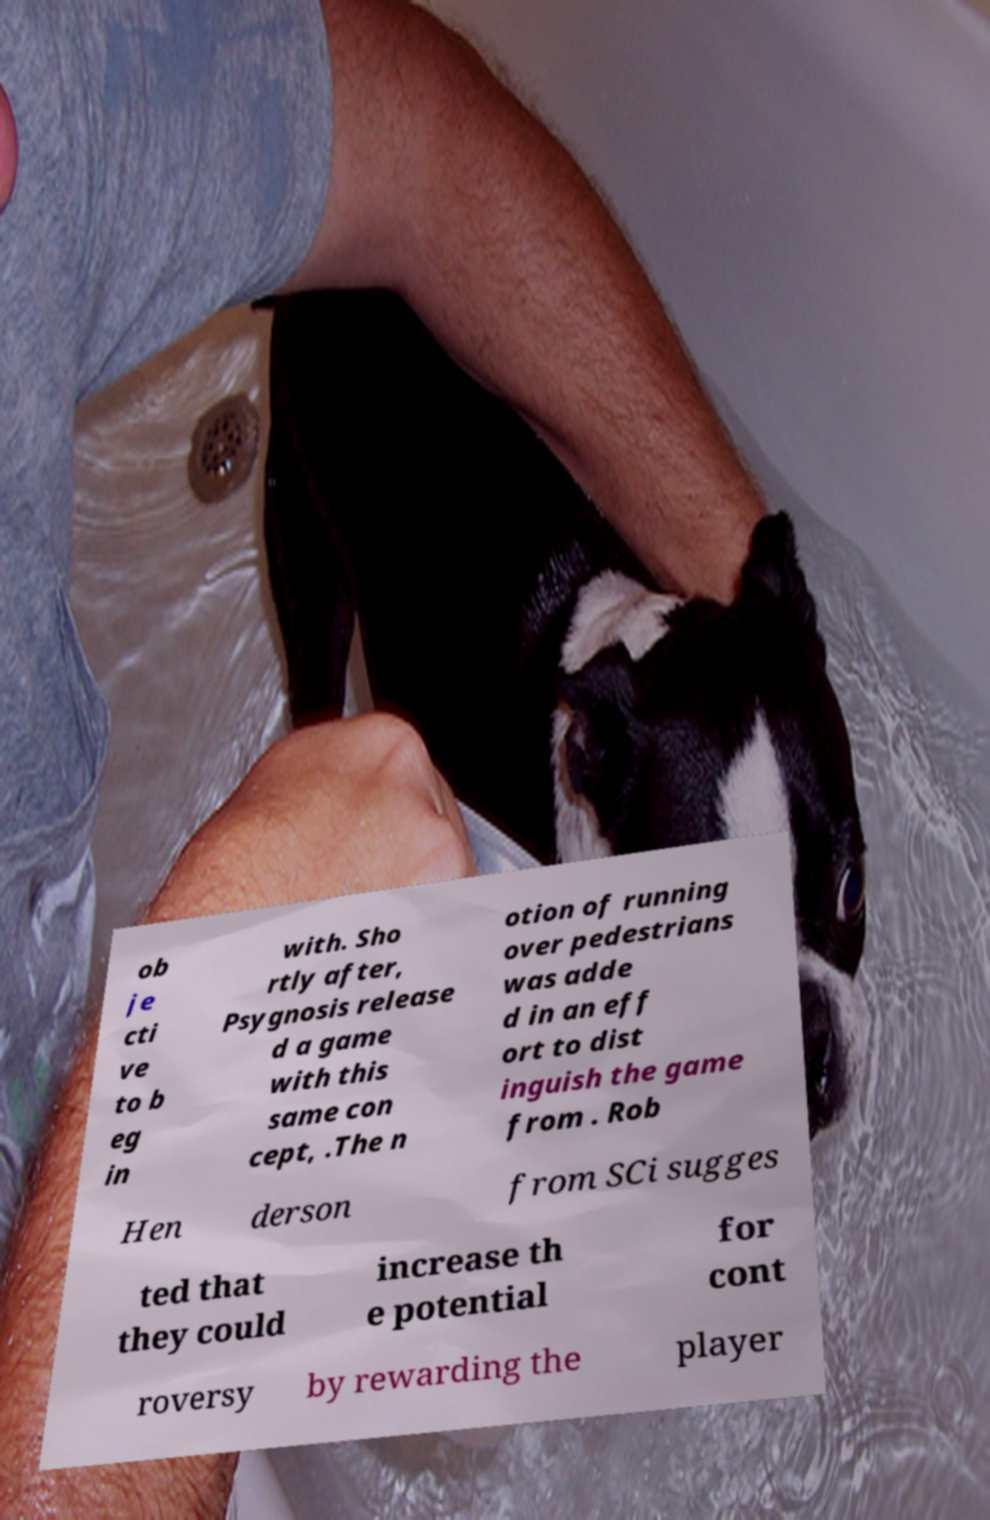Could you assist in decoding the text presented in this image and type it out clearly? ob je cti ve to b eg in with. Sho rtly after, Psygnosis release d a game with this same con cept, .The n otion of running over pedestrians was adde d in an eff ort to dist inguish the game from . Rob Hen derson from SCi sugges ted that they could increase th e potential for cont roversy by rewarding the player 